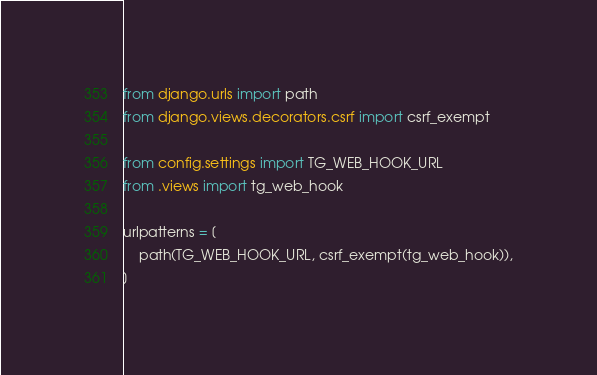Convert code to text. <code><loc_0><loc_0><loc_500><loc_500><_Python_>from django.urls import path
from django.views.decorators.csrf import csrf_exempt

from config.settings import TG_WEB_HOOK_URL
from .views import tg_web_hook

urlpatterns = [
    path(TG_WEB_HOOK_URL, csrf_exempt(tg_web_hook)),
]
</code> 